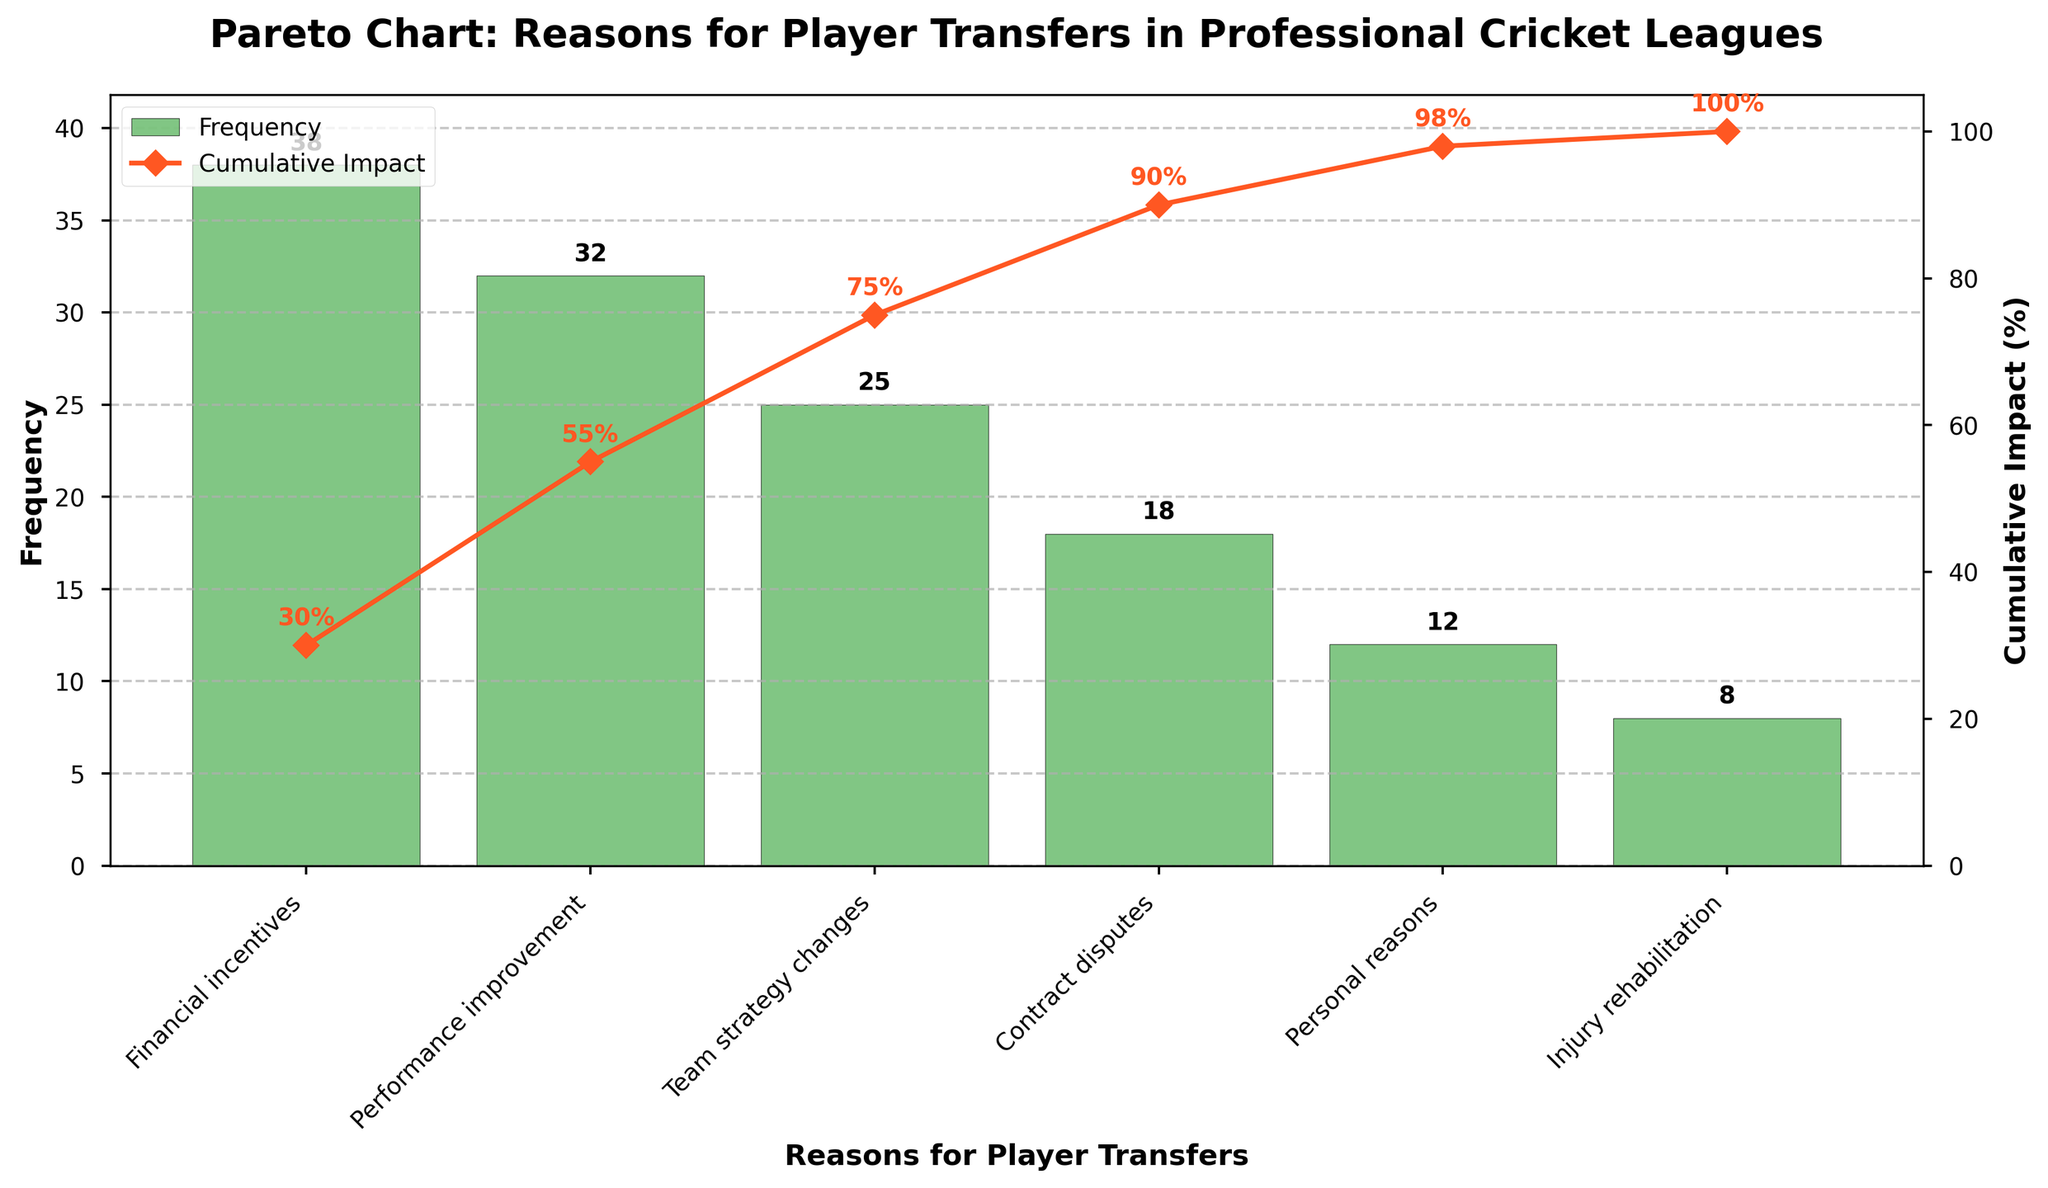What is the most common reason for player transfers? The most common reason is the one with the highest bar in the chart. The tallest bar corresponds to "Financial incentives" with a frequency of 38.
Answer: Financial incentives What percentage of the cumulative impact is achieved by the three most common reasons? Locate the cumulative impact values for the first three reasons: 30% (Financial incentives), 55% (Performance improvement), 75% (Team strategy changes). Thus, the cumulative impact is 75%.
Answer: 75% Which reasons for player transfers contribute to the last 10% of the cumulative impact? Find the cumulative impact values near 90% and 100%. The last 10% starts around 90%, so "Contract disputes" (90%), "Personal reasons" (98%), and "Injury rehabilitation" (100%).
Answer: Contract disputes, Personal reasons, Injury rehabilitation What is the combined frequency of reasons related to personal and health aspects? Sum the frequencies for "Personal reasons" and "Injury rehabilitation": 12 and 8 respectively. 12 + 8 = 20.
Answer: 20 How many reasons have a cumulative impact greater than or equal to 55%? Identify where the cumulative impact reaches 55%. The reasons are "Financial incentives" (30%), "Performance improvement" (55%), and include any reasons above this value. There are 4 such reasons: "Financial incentives", "Performance improvement", "Team strategy changes", and "Contract disputes".
Answer: 4 Which reason has the smallest impact in terms of frequency? The reason with the smallest bar represents the smallest frequency. "Injury rehabilitation" has a frequency of 8.
Answer: Injury rehabilitation What is the difference in frequency between the most common and least common reasons? Subtract the frequency of the least common reason from the frequency of the most common reason: 38 (Financial incentives) - 8 (Injury rehabilitation) = 30.
Answer: 30 What cumulative impact percentage is achieved after accounting for "Contract disputes"? Find the cumulative impact value for "Contract disputes": 90%.
Answer: 90% What is the average frequency of the top three reasons for player transfers? Calculate the average for "Financial incentives" (38), "Performance improvement" (32), and "Team strategy changes" (25). (38 + 32 + 25) / 3 ≈ 31.67.
Answer: 31.67 Which reason causes player transfers due to strategy adjustments? Identify the reason related to team strategy from the options listed. This corresponds to "Team strategy changes" which has a frequency of 25.
Answer: Team strategy changes 